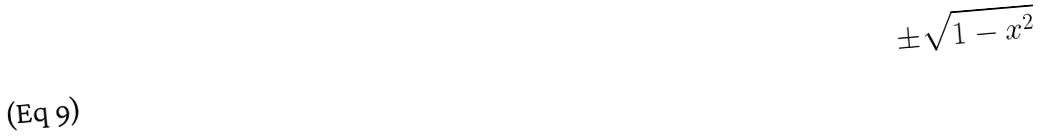Convert formula to latex. <formula><loc_0><loc_0><loc_500><loc_500>\pm \sqrt { 1 - x ^ { 2 } }</formula> 